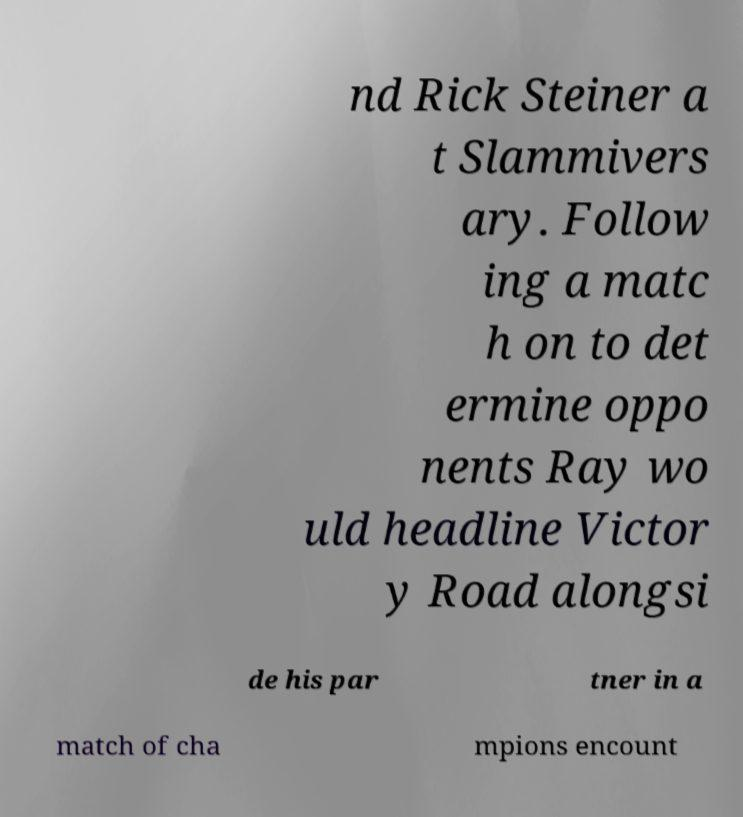Can you accurately transcribe the text from the provided image for me? nd Rick Steiner a t Slammivers ary. Follow ing a matc h on to det ermine oppo nents Ray wo uld headline Victor y Road alongsi de his par tner in a match of cha mpions encount 